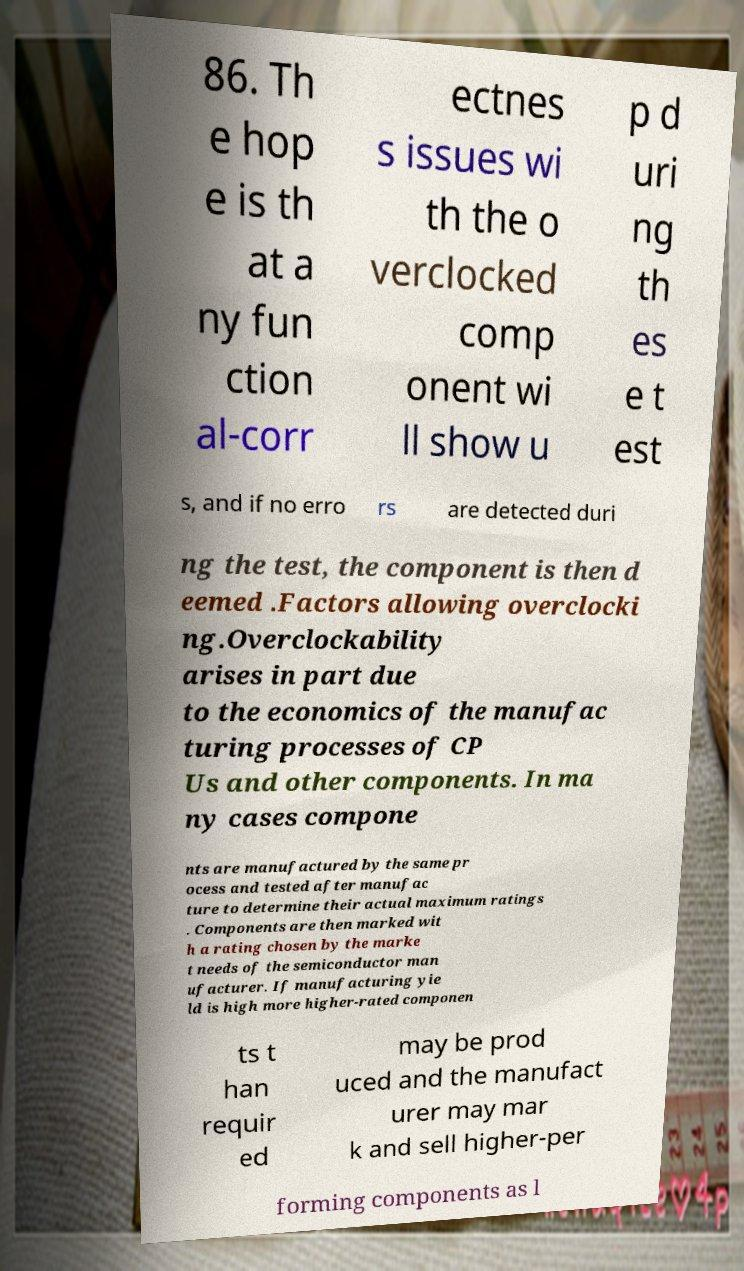Could you assist in decoding the text presented in this image and type it out clearly? 86. Th e hop e is th at a ny fun ction al-corr ectnes s issues wi th the o verclocked comp onent wi ll show u p d uri ng th es e t est s, and if no erro rs are detected duri ng the test, the component is then d eemed .Factors allowing overclocki ng.Overclockability arises in part due to the economics of the manufac turing processes of CP Us and other components. In ma ny cases compone nts are manufactured by the same pr ocess and tested after manufac ture to determine their actual maximum ratings . Components are then marked wit h a rating chosen by the marke t needs of the semiconductor man ufacturer. If manufacturing yie ld is high more higher-rated componen ts t han requir ed may be prod uced and the manufact urer may mar k and sell higher-per forming components as l 